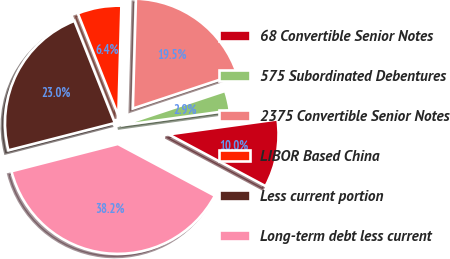<chart> <loc_0><loc_0><loc_500><loc_500><pie_chart><fcel>68 Convertible Senior Notes<fcel>575 Subordinated Debentures<fcel>2375 Convertible Senior Notes<fcel>LIBOR Based China<fcel>Less current portion<fcel>Long-term debt less current<nl><fcel>9.98%<fcel>2.92%<fcel>19.46%<fcel>6.45%<fcel>22.99%<fcel>38.2%<nl></chart> 